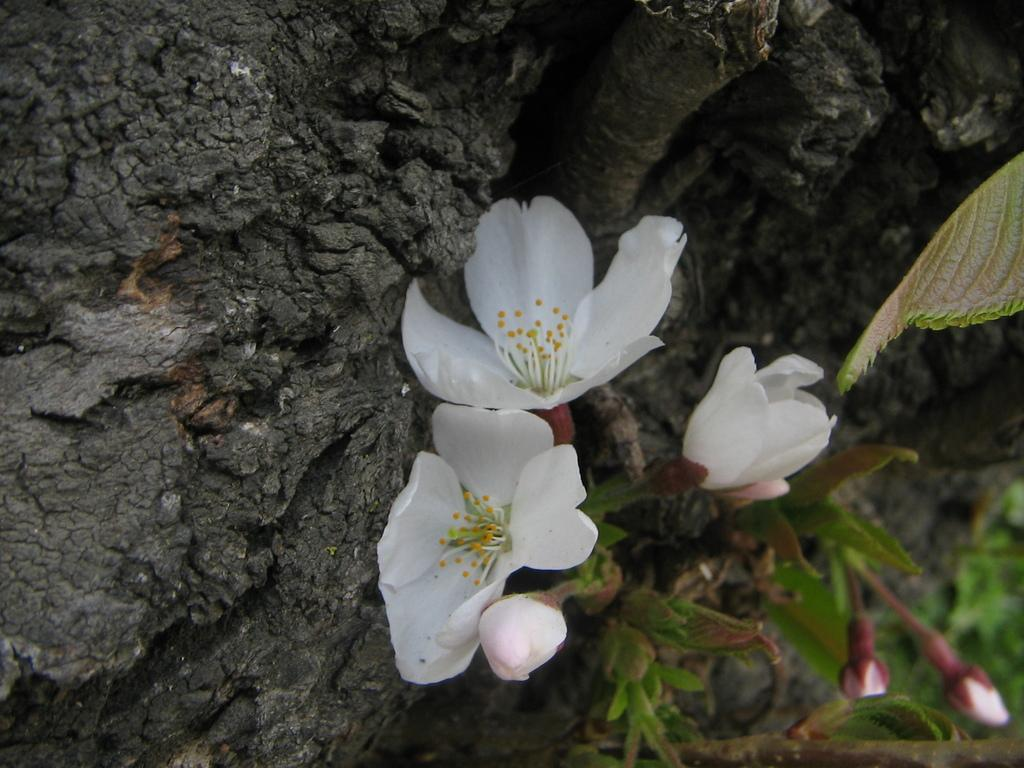Where was the picture taken? The picture was clicked outside. What is the main subject in the center of the image? There are white color flowers in the center of the image. What can be seen on the right side of the image? There is a plant on the right side of the image. What is the current state of the plant? The plant has buds. What is visible in the background of the image? There is a rock in the background of the image. What type of dress is the worm wearing in the image? There is no worm or dress present in the image. How does the kite fly in the image? There is no kite present in the image. 